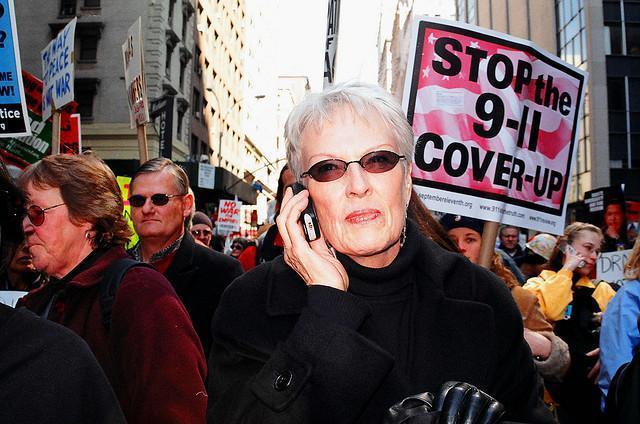How many people are there?
Give a very brief answer. 7. 